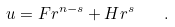Convert formula to latex. <formula><loc_0><loc_0><loc_500><loc_500>u = F r ^ { n - s } + H r ^ { s } \quad .</formula> 